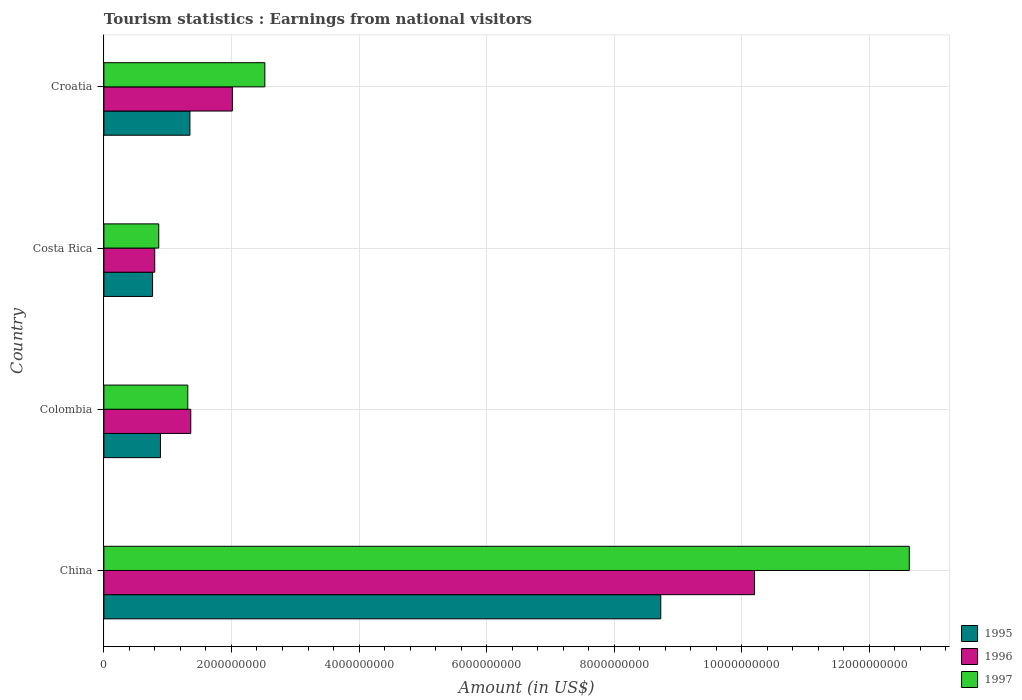How many different coloured bars are there?
Your response must be concise. 3. How many groups of bars are there?
Make the answer very short. 4. Are the number of bars per tick equal to the number of legend labels?
Provide a succinct answer. Yes. Are the number of bars on each tick of the Y-axis equal?
Your answer should be compact. Yes. What is the label of the 1st group of bars from the top?
Your answer should be compact. Croatia. What is the earnings from national visitors in 1997 in China?
Ensure brevity in your answer.  1.26e+1. Across all countries, what is the maximum earnings from national visitors in 1997?
Give a very brief answer. 1.26e+1. Across all countries, what is the minimum earnings from national visitors in 1996?
Your answer should be very brief. 7.97e+08. In which country was the earnings from national visitors in 1996 maximum?
Your response must be concise. China. What is the total earnings from national visitors in 1996 in the graph?
Ensure brevity in your answer.  1.44e+1. What is the difference between the earnings from national visitors in 1995 in China and that in Colombia?
Offer a very short reply. 7.84e+09. What is the difference between the earnings from national visitors in 1996 in Croatia and the earnings from national visitors in 1995 in China?
Provide a short and direct response. -6.72e+09. What is the average earnings from national visitors in 1997 per country?
Your answer should be very brief. 4.33e+09. What is the difference between the earnings from national visitors in 1995 and earnings from national visitors in 1996 in Croatia?
Your answer should be very brief. -6.65e+08. What is the ratio of the earnings from national visitors in 1997 in Costa Rica to that in Croatia?
Your answer should be compact. 0.34. Is the earnings from national visitors in 1995 in China less than that in Colombia?
Keep it short and to the point. No. What is the difference between the highest and the second highest earnings from national visitors in 1996?
Your answer should be compact. 8.19e+09. What is the difference between the highest and the lowest earnings from national visitors in 1997?
Ensure brevity in your answer.  1.18e+1. In how many countries, is the earnings from national visitors in 1996 greater than the average earnings from national visitors in 1996 taken over all countries?
Make the answer very short. 1. Is the sum of the earnings from national visitors in 1997 in China and Costa Rica greater than the maximum earnings from national visitors in 1995 across all countries?
Keep it short and to the point. Yes. What does the 3rd bar from the top in Colombia represents?
Offer a very short reply. 1995. Is it the case that in every country, the sum of the earnings from national visitors in 1995 and earnings from national visitors in 1996 is greater than the earnings from national visitors in 1997?
Offer a very short reply. Yes. Are all the bars in the graph horizontal?
Ensure brevity in your answer.  Yes. What is the difference between two consecutive major ticks on the X-axis?
Offer a terse response. 2.00e+09. Are the values on the major ticks of X-axis written in scientific E-notation?
Your answer should be very brief. No. Does the graph contain any zero values?
Keep it short and to the point. No. Does the graph contain grids?
Keep it short and to the point. Yes. Where does the legend appear in the graph?
Provide a succinct answer. Bottom right. How many legend labels are there?
Keep it short and to the point. 3. What is the title of the graph?
Ensure brevity in your answer.  Tourism statistics : Earnings from national visitors. What is the label or title of the X-axis?
Give a very brief answer. Amount (in US$). What is the Amount (in US$) in 1995 in China?
Offer a terse response. 8.73e+09. What is the Amount (in US$) in 1996 in China?
Provide a short and direct response. 1.02e+1. What is the Amount (in US$) of 1997 in China?
Your answer should be very brief. 1.26e+1. What is the Amount (in US$) of 1995 in Colombia?
Offer a very short reply. 8.87e+08. What is the Amount (in US$) of 1996 in Colombia?
Your response must be concise. 1.36e+09. What is the Amount (in US$) of 1997 in Colombia?
Give a very brief answer. 1.32e+09. What is the Amount (in US$) of 1995 in Costa Rica?
Provide a short and direct response. 7.63e+08. What is the Amount (in US$) in 1996 in Costa Rica?
Make the answer very short. 7.97e+08. What is the Amount (in US$) in 1997 in Costa Rica?
Provide a succinct answer. 8.60e+08. What is the Amount (in US$) in 1995 in Croatia?
Give a very brief answer. 1.35e+09. What is the Amount (in US$) of 1996 in Croatia?
Offer a terse response. 2.01e+09. What is the Amount (in US$) of 1997 in Croatia?
Your answer should be very brief. 2.52e+09. Across all countries, what is the maximum Amount (in US$) in 1995?
Give a very brief answer. 8.73e+09. Across all countries, what is the maximum Amount (in US$) in 1996?
Keep it short and to the point. 1.02e+1. Across all countries, what is the maximum Amount (in US$) in 1997?
Provide a succinct answer. 1.26e+1. Across all countries, what is the minimum Amount (in US$) in 1995?
Ensure brevity in your answer.  7.63e+08. Across all countries, what is the minimum Amount (in US$) in 1996?
Offer a terse response. 7.97e+08. Across all countries, what is the minimum Amount (in US$) of 1997?
Provide a succinct answer. 8.60e+08. What is the total Amount (in US$) of 1995 in the graph?
Keep it short and to the point. 1.17e+1. What is the total Amount (in US$) of 1996 in the graph?
Provide a short and direct response. 1.44e+1. What is the total Amount (in US$) of 1997 in the graph?
Keep it short and to the point. 1.73e+1. What is the difference between the Amount (in US$) of 1995 in China and that in Colombia?
Offer a very short reply. 7.84e+09. What is the difference between the Amount (in US$) of 1996 in China and that in Colombia?
Provide a succinct answer. 8.84e+09. What is the difference between the Amount (in US$) in 1997 in China and that in Colombia?
Your response must be concise. 1.13e+1. What is the difference between the Amount (in US$) in 1995 in China and that in Costa Rica?
Provide a short and direct response. 7.97e+09. What is the difference between the Amount (in US$) of 1996 in China and that in Costa Rica?
Your response must be concise. 9.40e+09. What is the difference between the Amount (in US$) in 1997 in China and that in Costa Rica?
Make the answer very short. 1.18e+1. What is the difference between the Amount (in US$) of 1995 in China and that in Croatia?
Give a very brief answer. 7.38e+09. What is the difference between the Amount (in US$) in 1996 in China and that in Croatia?
Keep it short and to the point. 8.19e+09. What is the difference between the Amount (in US$) in 1997 in China and that in Croatia?
Keep it short and to the point. 1.01e+1. What is the difference between the Amount (in US$) of 1995 in Colombia and that in Costa Rica?
Make the answer very short. 1.24e+08. What is the difference between the Amount (in US$) in 1996 in Colombia and that in Costa Rica?
Provide a succinct answer. 5.65e+08. What is the difference between the Amount (in US$) of 1997 in Colombia and that in Costa Rica?
Offer a very short reply. 4.55e+08. What is the difference between the Amount (in US$) in 1995 in Colombia and that in Croatia?
Offer a very short reply. -4.62e+08. What is the difference between the Amount (in US$) in 1996 in Colombia and that in Croatia?
Give a very brief answer. -6.52e+08. What is the difference between the Amount (in US$) of 1997 in Colombia and that in Croatia?
Your answer should be compact. -1.21e+09. What is the difference between the Amount (in US$) of 1995 in Costa Rica and that in Croatia?
Provide a short and direct response. -5.86e+08. What is the difference between the Amount (in US$) in 1996 in Costa Rica and that in Croatia?
Your response must be concise. -1.22e+09. What is the difference between the Amount (in US$) in 1997 in Costa Rica and that in Croatia?
Your answer should be compact. -1.66e+09. What is the difference between the Amount (in US$) in 1995 in China and the Amount (in US$) in 1996 in Colombia?
Give a very brief answer. 7.37e+09. What is the difference between the Amount (in US$) in 1995 in China and the Amount (in US$) in 1997 in Colombia?
Your answer should be compact. 7.42e+09. What is the difference between the Amount (in US$) in 1996 in China and the Amount (in US$) in 1997 in Colombia?
Your answer should be compact. 8.88e+09. What is the difference between the Amount (in US$) of 1995 in China and the Amount (in US$) of 1996 in Costa Rica?
Your answer should be very brief. 7.93e+09. What is the difference between the Amount (in US$) in 1995 in China and the Amount (in US$) in 1997 in Costa Rica?
Give a very brief answer. 7.87e+09. What is the difference between the Amount (in US$) in 1996 in China and the Amount (in US$) in 1997 in Costa Rica?
Make the answer very short. 9.34e+09. What is the difference between the Amount (in US$) in 1995 in China and the Amount (in US$) in 1996 in Croatia?
Offer a terse response. 6.72e+09. What is the difference between the Amount (in US$) in 1995 in China and the Amount (in US$) in 1997 in Croatia?
Offer a very short reply. 6.21e+09. What is the difference between the Amount (in US$) of 1996 in China and the Amount (in US$) of 1997 in Croatia?
Give a very brief answer. 7.68e+09. What is the difference between the Amount (in US$) in 1995 in Colombia and the Amount (in US$) in 1996 in Costa Rica?
Provide a succinct answer. 9.00e+07. What is the difference between the Amount (in US$) of 1995 in Colombia and the Amount (in US$) of 1997 in Costa Rica?
Your answer should be very brief. 2.70e+07. What is the difference between the Amount (in US$) of 1996 in Colombia and the Amount (in US$) of 1997 in Costa Rica?
Keep it short and to the point. 5.02e+08. What is the difference between the Amount (in US$) in 1995 in Colombia and the Amount (in US$) in 1996 in Croatia?
Keep it short and to the point. -1.13e+09. What is the difference between the Amount (in US$) of 1995 in Colombia and the Amount (in US$) of 1997 in Croatia?
Provide a short and direct response. -1.64e+09. What is the difference between the Amount (in US$) of 1996 in Colombia and the Amount (in US$) of 1997 in Croatia?
Give a very brief answer. -1.16e+09. What is the difference between the Amount (in US$) of 1995 in Costa Rica and the Amount (in US$) of 1996 in Croatia?
Your answer should be compact. -1.25e+09. What is the difference between the Amount (in US$) in 1995 in Costa Rica and the Amount (in US$) in 1997 in Croatia?
Your answer should be compact. -1.76e+09. What is the difference between the Amount (in US$) in 1996 in Costa Rica and the Amount (in US$) in 1997 in Croatia?
Give a very brief answer. -1.73e+09. What is the average Amount (in US$) in 1995 per country?
Ensure brevity in your answer.  2.93e+09. What is the average Amount (in US$) in 1996 per country?
Offer a terse response. 3.59e+09. What is the average Amount (in US$) of 1997 per country?
Your answer should be compact. 4.33e+09. What is the difference between the Amount (in US$) in 1995 and Amount (in US$) in 1996 in China?
Keep it short and to the point. -1.47e+09. What is the difference between the Amount (in US$) of 1995 and Amount (in US$) of 1997 in China?
Your answer should be compact. -3.90e+09. What is the difference between the Amount (in US$) in 1996 and Amount (in US$) in 1997 in China?
Provide a succinct answer. -2.43e+09. What is the difference between the Amount (in US$) in 1995 and Amount (in US$) in 1996 in Colombia?
Provide a short and direct response. -4.75e+08. What is the difference between the Amount (in US$) of 1995 and Amount (in US$) of 1997 in Colombia?
Provide a succinct answer. -4.28e+08. What is the difference between the Amount (in US$) of 1996 and Amount (in US$) of 1997 in Colombia?
Provide a succinct answer. 4.70e+07. What is the difference between the Amount (in US$) in 1995 and Amount (in US$) in 1996 in Costa Rica?
Keep it short and to the point. -3.40e+07. What is the difference between the Amount (in US$) of 1995 and Amount (in US$) of 1997 in Costa Rica?
Make the answer very short. -9.70e+07. What is the difference between the Amount (in US$) of 1996 and Amount (in US$) of 1997 in Costa Rica?
Offer a very short reply. -6.30e+07. What is the difference between the Amount (in US$) of 1995 and Amount (in US$) of 1996 in Croatia?
Offer a very short reply. -6.65e+08. What is the difference between the Amount (in US$) in 1995 and Amount (in US$) in 1997 in Croatia?
Give a very brief answer. -1.17e+09. What is the difference between the Amount (in US$) of 1996 and Amount (in US$) of 1997 in Croatia?
Your answer should be compact. -5.09e+08. What is the ratio of the Amount (in US$) of 1995 in China to that in Colombia?
Give a very brief answer. 9.84. What is the ratio of the Amount (in US$) of 1996 in China to that in Colombia?
Ensure brevity in your answer.  7.49. What is the ratio of the Amount (in US$) of 1997 in China to that in Colombia?
Offer a terse response. 9.6. What is the ratio of the Amount (in US$) of 1995 in China to that in Costa Rica?
Make the answer very short. 11.44. What is the ratio of the Amount (in US$) in 1996 in China to that in Costa Rica?
Ensure brevity in your answer.  12.8. What is the ratio of the Amount (in US$) of 1997 in China to that in Costa Rica?
Ensure brevity in your answer.  14.68. What is the ratio of the Amount (in US$) of 1995 in China to that in Croatia?
Ensure brevity in your answer.  6.47. What is the ratio of the Amount (in US$) in 1996 in China to that in Croatia?
Make the answer very short. 5.06. What is the ratio of the Amount (in US$) of 1997 in China to that in Croatia?
Provide a short and direct response. 5. What is the ratio of the Amount (in US$) in 1995 in Colombia to that in Costa Rica?
Ensure brevity in your answer.  1.16. What is the ratio of the Amount (in US$) in 1996 in Colombia to that in Costa Rica?
Your answer should be compact. 1.71. What is the ratio of the Amount (in US$) in 1997 in Colombia to that in Costa Rica?
Keep it short and to the point. 1.53. What is the ratio of the Amount (in US$) of 1995 in Colombia to that in Croatia?
Make the answer very short. 0.66. What is the ratio of the Amount (in US$) in 1996 in Colombia to that in Croatia?
Make the answer very short. 0.68. What is the ratio of the Amount (in US$) in 1997 in Colombia to that in Croatia?
Your answer should be very brief. 0.52. What is the ratio of the Amount (in US$) in 1995 in Costa Rica to that in Croatia?
Your response must be concise. 0.57. What is the ratio of the Amount (in US$) in 1996 in Costa Rica to that in Croatia?
Make the answer very short. 0.4. What is the ratio of the Amount (in US$) in 1997 in Costa Rica to that in Croatia?
Keep it short and to the point. 0.34. What is the difference between the highest and the second highest Amount (in US$) of 1995?
Your response must be concise. 7.38e+09. What is the difference between the highest and the second highest Amount (in US$) in 1996?
Provide a succinct answer. 8.19e+09. What is the difference between the highest and the second highest Amount (in US$) of 1997?
Provide a succinct answer. 1.01e+1. What is the difference between the highest and the lowest Amount (in US$) in 1995?
Offer a terse response. 7.97e+09. What is the difference between the highest and the lowest Amount (in US$) in 1996?
Provide a short and direct response. 9.40e+09. What is the difference between the highest and the lowest Amount (in US$) of 1997?
Provide a succinct answer. 1.18e+1. 